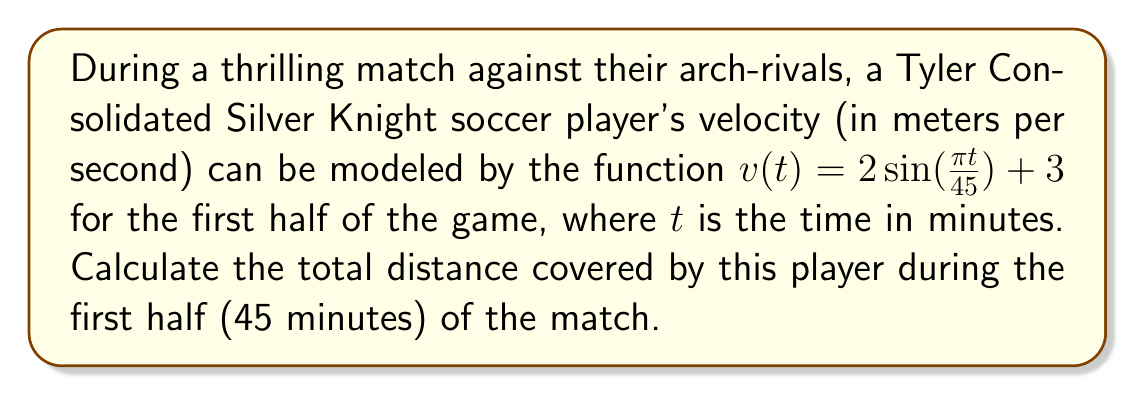Can you answer this question? To solve this problem, we need to follow these steps:

1) The distance covered is the integral of velocity over time. We need to integrate $v(t)$ from $t=0$ to $t=45$.

2) The integral we need to evaluate is:

   $$\int_0^{45} (2\sin(\frac{\pi t}{45}) + 3) dt$$

3) Let's break this into two parts:

   $$\int_0^{45} 2\sin(\frac{\pi t}{45}) dt + \int_0^{45} 3 dt$$

4) For the first part, we can use the substitution $u = \frac{\pi t}{45}$, so $du = \frac{\pi}{45} dt$ or $dt = \frac{45}{\pi} du$:

   $$2 \cdot \frac{45}{\pi} \int_0^{\pi} \sin(u) du = \frac{90}{\pi} [-\cos(u)]_0^{\pi} = \frac{90}{\pi} [-(-1) - (-1)] = \frac{180}{\pi}$$

5) The second part is straightforward:

   $$3 \int_0^{45} dt = 3 \cdot 45 = 135$$

6) Adding these together:

   $$\frac{180}{\pi} + 135 \approx 192.3$$

Therefore, the Silver Knight player covered approximately 192.3 meters during the first half of the match.
Answer: $192.3$ meters 